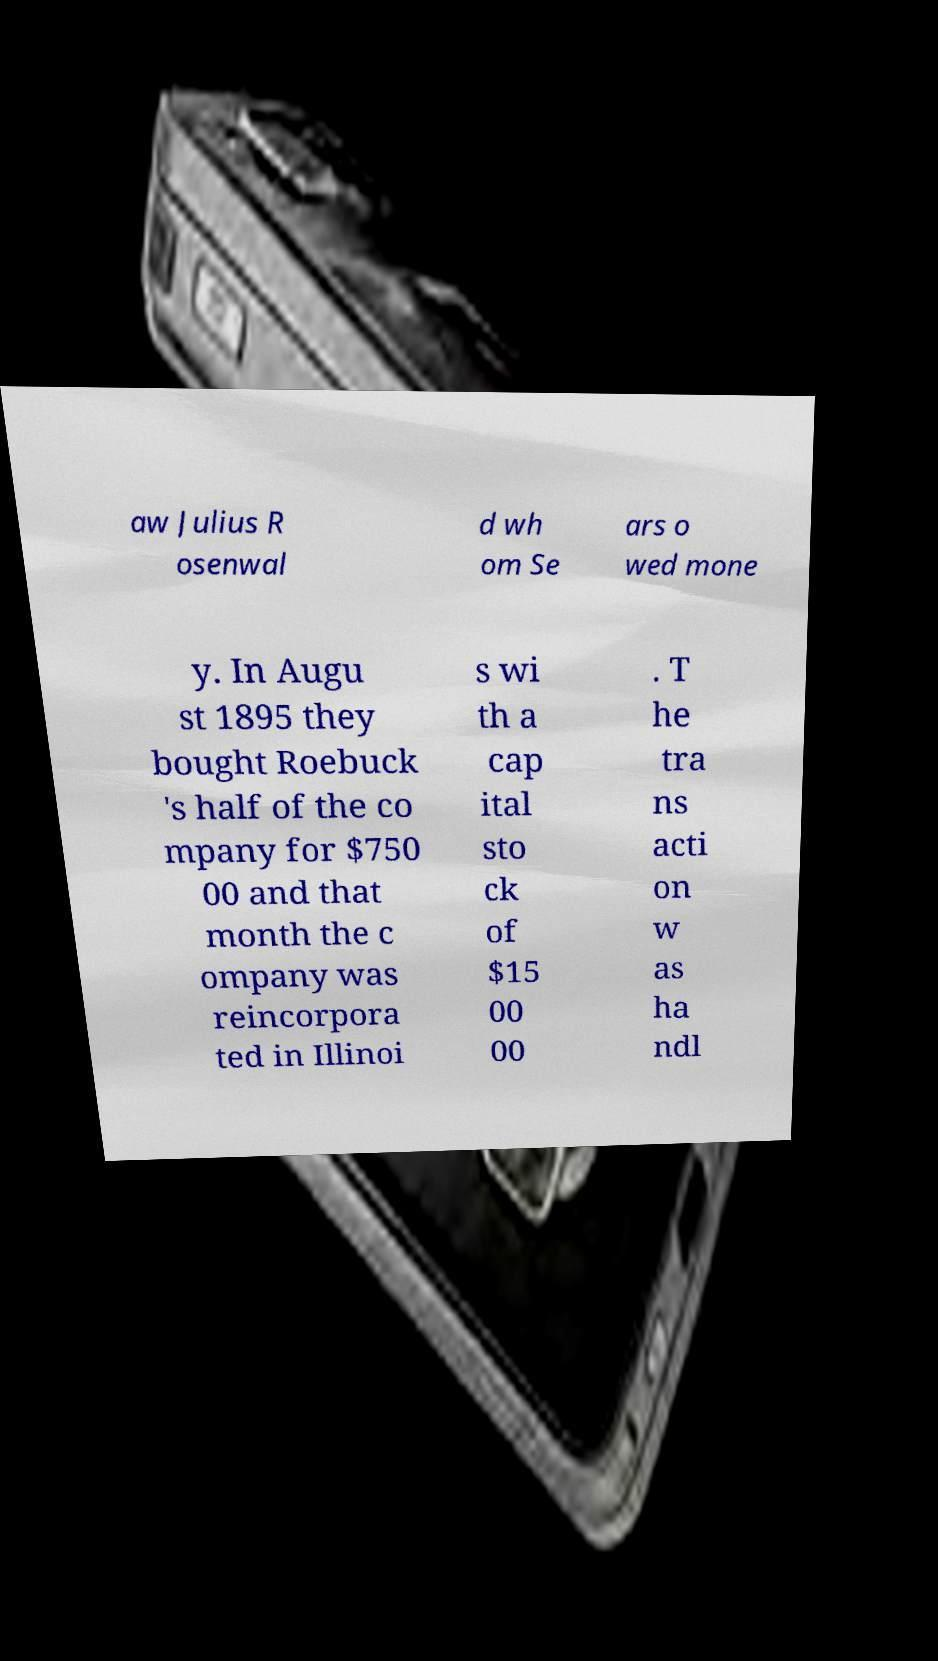Can you read and provide the text displayed in the image?This photo seems to have some interesting text. Can you extract and type it out for me? aw Julius R osenwal d wh om Se ars o wed mone y. In Augu st 1895 they bought Roebuck 's half of the co mpany for $750 00 and that month the c ompany was reincorpora ted in Illinoi s wi th a cap ital sto ck of $15 00 00 . T he tra ns acti on w as ha ndl 